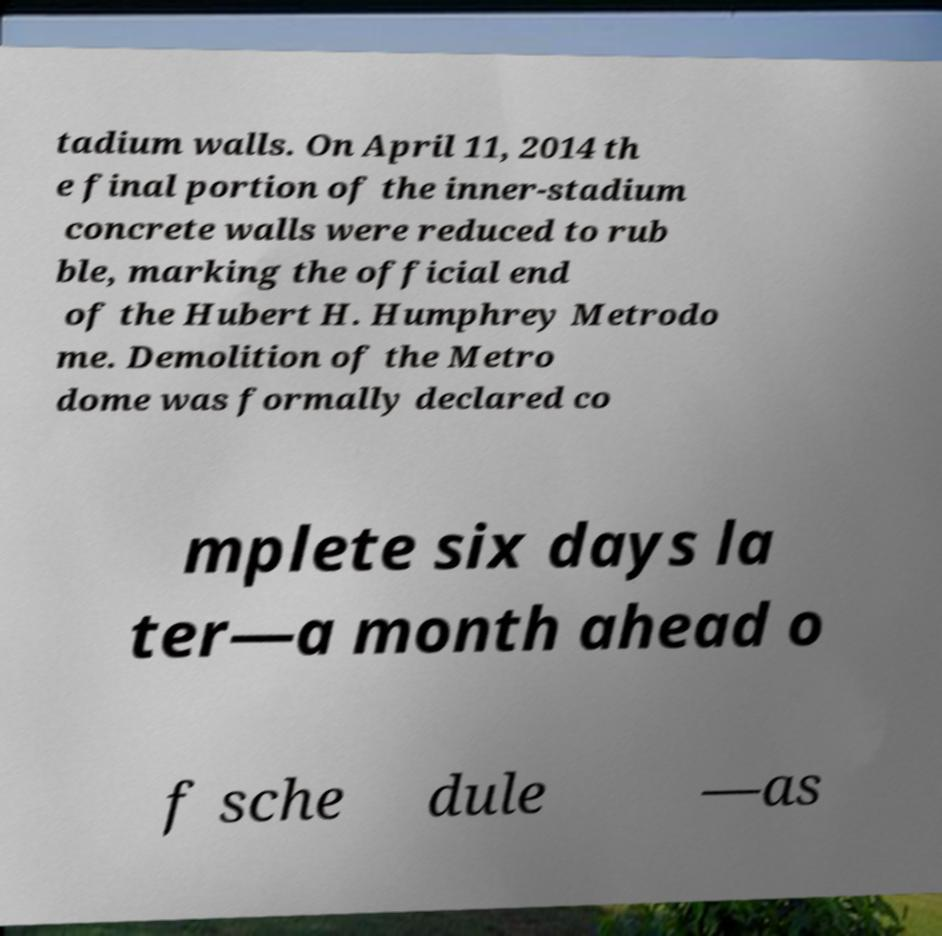I need the written content from this picture converted into text. Can you do that? tadium walls. On April 11, 2014 th e final portion of the inner-stadium concrete walls were reduced to rub ble, marking the official end of the Hubert H. Humphrey Metrodo me. Demolition of the Metro dome was formally declared co mplete six days la ter—a month ahead o f sche dule —as 